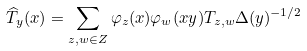Convert formula to latex. <formula><loc_0><loc_0><loc_500><loc_500>\widehat { T } _ { y } ( x ) = \sum _ { z , w \in Z } \varphi _ { z } ( x ) \varphi _ { w } ( x y ) T _ { z , w } \Delta ( y ) ^ { - 1 / 2 } \</formula> 